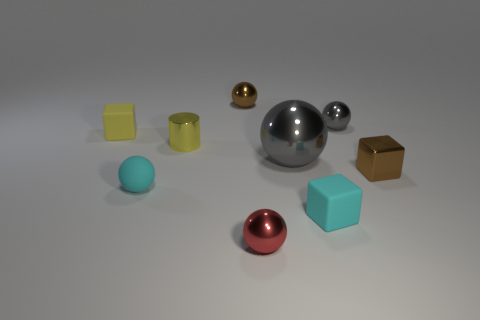Subtract all small yellow blocks. How many blocks are left? 2 Subtract all cyan blocks. How many gray spheres are left? 2 Subtract all cyan cubes. How many cubes are left? 2 Subtract all cylinders. How many objects are left? 8 Subtract 1 blocks. How many blocks are left? 2 Subtract 0 cyan cylinders. How many objects are left? 9 Subtract all yellow blocks. Subtract all blue cylinders. How many blocks are left? 2 Subtract all purple matte spheres. Subtract all tiny red things. How many objects are left? 8 Add 2 rubber objects. How many rubber objects are left? 5 Add 7 cylinders. How many cylinders exist? 8 